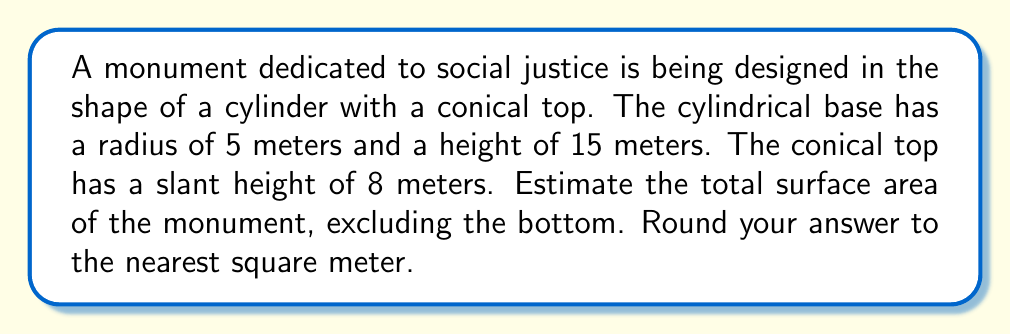Provide a solution to this math problem. Let's break this down step-by-step:

1) The monument consists of two parts: a cylindrical base and a conical top.

2) For the cylindrical base:
   - Radius (r) = 5 m
   - Height (h) = 15 m
   - Surface area of cylinder (excluding top and bottom) = $2\pi rh$
   - $SA_{cylinder} = 2\pi(5)(15) = 150\pi$ m²

3) For the conical top:
   - Slant height (s) = 8 m
   - We need to find the radius of the base of the cone (which is the same as the cylinder's radius)
   - Surface area of cone = $\pi rs$
   - $SA_{cone} = \pi(5)(8) = 40\pi$ m²

4) Total surface area:
   $SA_{total} = SA_{cylinder} + SA_{cone} = 150\pi + 40\pi = 190\pi$ m²

5) Converting to a numerical value:
   $190\pi \approx 596.9$ m²

6) Rounding to the nearest square meter:
   597 m²

[asy]
import geometry;

size(200);

draw(circle((0,0),5));
draw((0,0)--(5,0));
draw((0,0)--(0,15));
draw((5,0)--(5,15));
draw((0,15)--(5,15));
draw((0,15)--(2.5,23));
draw((5,15)--(2.5,23));

label("5m", (2.5,0), S);
label("15m", (5.5,7.5), E);
label("8m", (4,19), NE);

[/asy]
Answer: 597 m² 